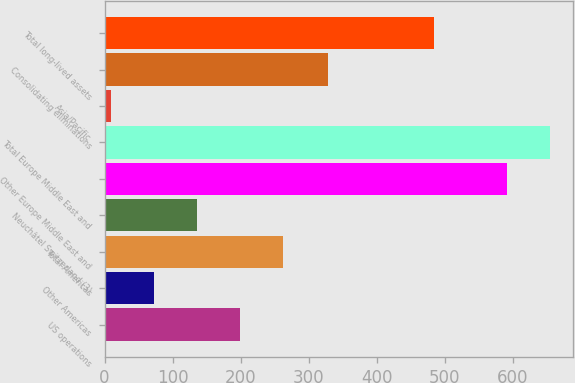Convert chart. <chart><loc_0><loc_0><loc_500><loc_500><bar_chart><fcel>US operations<fcel>Other Americas<fcel>Total Americas<fcel>Neuchâtel Switzerland (3)<fcel>Other Europe Middle East and<fcel>Total Europe Middle East and<fcel>Asia/Pacific<fcel>Consolidating eliminations<fcel>Total long-lived assets<nl><fcel>198.94<fcel>72.58<fcel>262.12<fcel>135.76<fcel>592<fcel>655.18<fcel>9.4<fcel>329.1<fcel>484.8<nl></chart> 